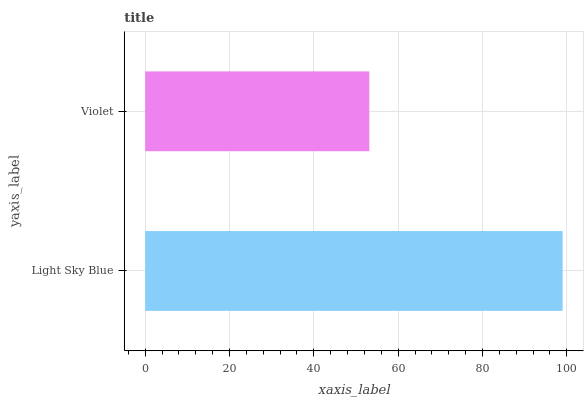Is Violet the minimum?
Answer yes or no. Yes. Is Light Sky Blue the maximum?
Answer yes or no. Yes. Is Violet the maximum?
Answer yes or no. No. Is Light Sky Blue greater than Violet?
Answer yes or no. Yes. Is Violet less than Light Sky Blue?
Answer yes or no. Yes. Is Violet greater than Light Sky Blue?
Answer yes or no. No. Is Light Sky Blue less than Violet?
Answer yes or no. No. Is Light Sky Blue the high median?
Answer yes or no. Yes. Is Violet the low median?
Answer yes or no. Yes. Is Violet the high median?
Answer yes or no. No. Is Light Sky Blue the low median?
Answer yes or no. No. 